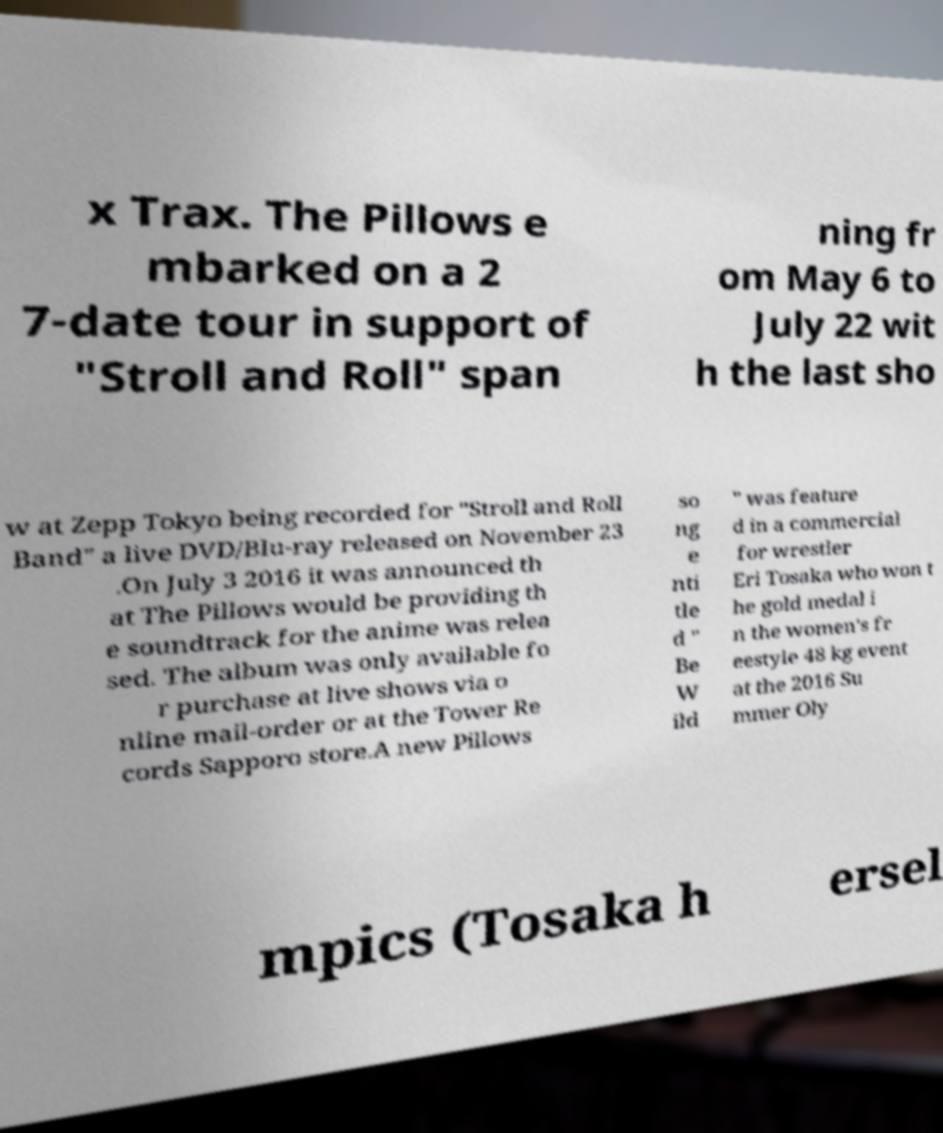Please identify and transcribe the text found in this image. x Trax. The Pillows e mbarked on a 2 7-date tour in support of "Stroll and Roll" span ning fr om May 6 to July 22 wit h the last sho w at Zepp Tokyo being recorded for "Stroll and Roll Band" a live DVD/Blu-ray released on November 23 .On July 3 2016 it was announced th at The Pillows would be providing th e soundtrack for the anime was relea sed. The album was only available fo r purchase at live shows via o nline mail-order or at the Tower Re cords Sapporo store.A new Pillows so ng e nti tle d " Be W ild " was feature d in a commercial for wrestler Eri Tosaka who won t he gold medal i n the women's fr eestyle 48 kg event at the 2016 Su mmer Oly mpics (Tosaka h ersel 